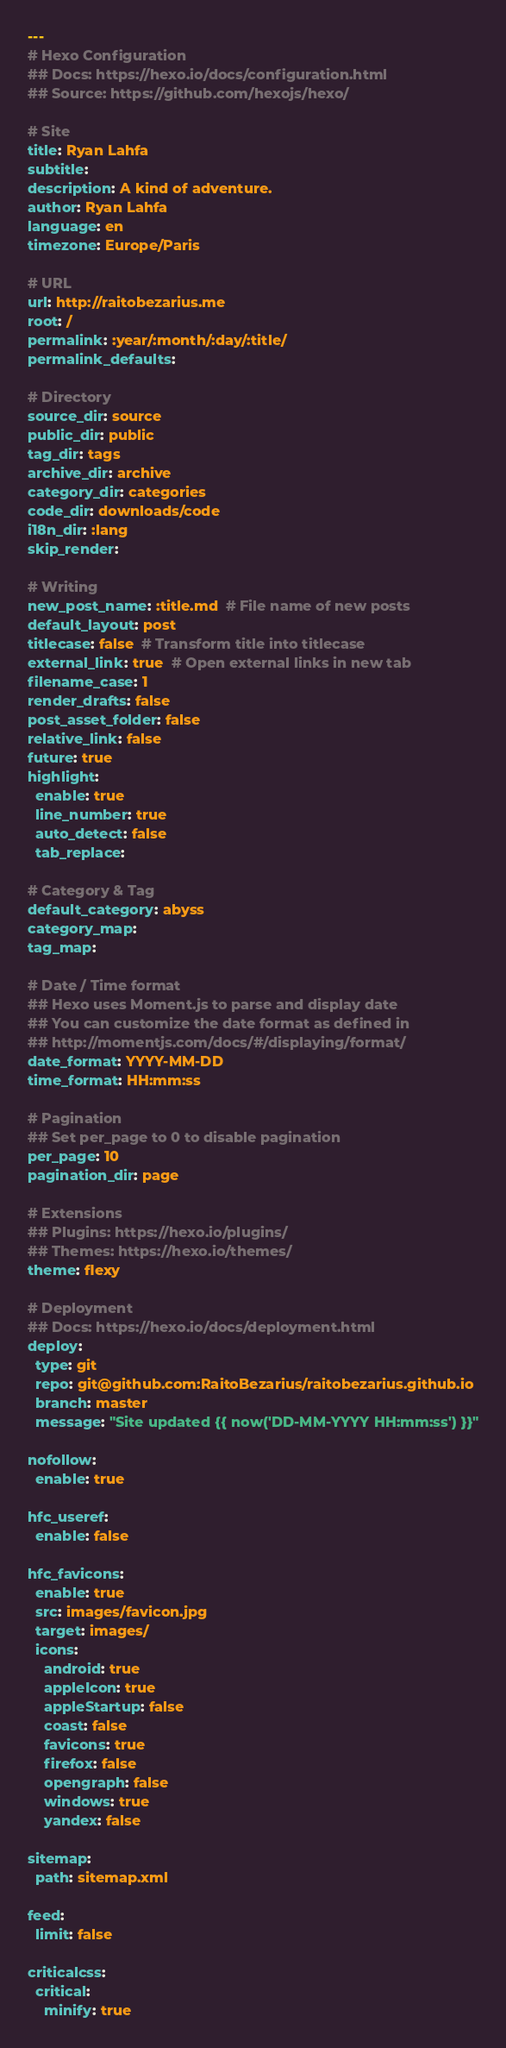<code> <loc_0><loc_0><loc_500><loc_500><_YAML_>---
# Hexo Configuration
## Docs: https://hexo.io/docs/configuration.html
## Source: https://github.com/hexojs/hexo/

# Site
title: Ryan Lahfa
subtitle:
description: A kind of adventure.
author: Ryan Lahfa
language: en
timezone: Europe/Paris

# URL
url: http://raitobezarius.me
root: /
permalink: :year/:month/:day/:title/
permalink_defaults:

# Directory
source_dir: source
public_dir: public
tag_dir: tags
archive_dir: archive
category_dir: categories
code_dir: downloads/code
i18n_dir: :lang
skip_render:

# Writing
new_post_name: :title.md  # File name of new posts
default_layout: post
titlecase: false  # Transform title into titlecase
external_link: true  # Open external links in new tab
filename_case: 1
render_drafts: false
post_asset_folder: false
relative_link: false
future: true
highlight:
  enable: true
  line_number: true
  auto_detect: false
  tab_replace:

# Category & Tag
default_category: abyss
category_map:
tag_map:

# Date / Time format
## Hexo uses Moment.js to parse and display date
## You can customize the date format as defined in
## http://momentjs.com/docs/#/displaying/format/
date_format: YYYY-MM-DD
time_format: HH:mm:ss

# Pagination
## Set per_page to 0 to disable pagination
per_page: 10
pagination_dir: page

# Extensions
## Plugins: https://hexo.io/plugins/
## Themes: https://hexo.io/themes/
theme: flexy

# Deployment
## Docs: https://hexo.io/docs/deployment.html
deploy:
  type: git
  repo: git@github.com:RaitoBezarius/raitobezarius.github.io
  branch: master
  message: "Site updated {{ now('DD-MM-YYYY HH:mm:ss') }}"

nofollow:
  enable: true

hfc_useref:
  enable: false

hfc_favicons:
  enable: true
  src: images/favicon.jpg
  target: images/
  icons:
    android: true
    appleIcon: true
    appleStartup: false
    coast: false
    favicons: true
    firefox: false
    opengraph: false
    windows: true
    yandex: false

sitemap:
  path: sitemap.xml

feed:
  limit: false

criticalcss:
  critical:
    minify: true
</code> 